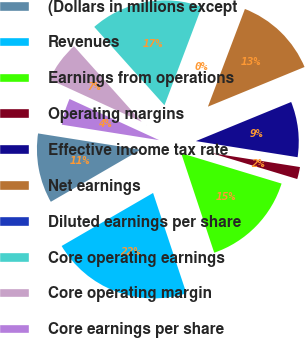<chart> <loc_0><loc_0><loc_500><loc_500><pie_chart><fcel>(Dollars in millions except<fcel>Revenues<fcel>Earnings from operations<fcel>Operating margins<fcel>Effective income tax rate<fcel>Net earnings<fcel>Diluted earnings per share<fcel>Core operating earnings<fcel>Core operating margin<fcel>Core earnings per share<nl><fcel>10.87%<fcel>21.74%<fcel>15.22%<fcel>2.18%<fcel>8.7%<fcel>13.04%<fcel>0.0%<fcel>17.39%<fcel>6.52%<fcel>4.35%<nl></chart> 